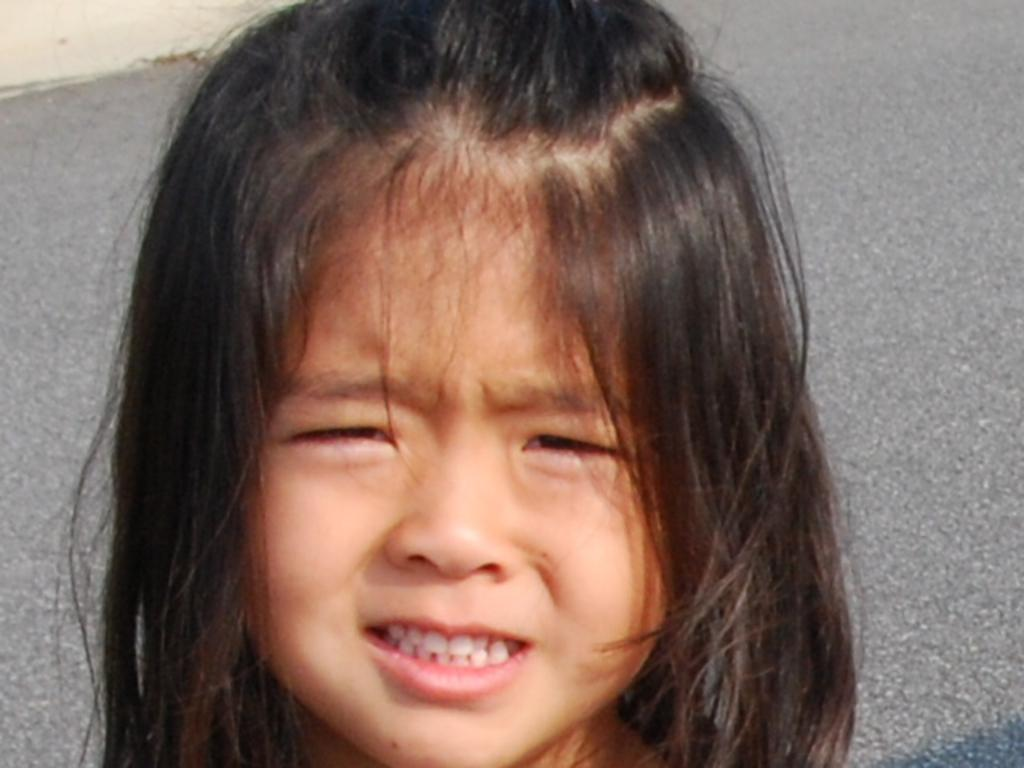Who is present in the image? There is a girl in the image. What is the girl doing in the image? The girl is crying in the image. Where is the girl located in the image? The girl is near a road in the image. What can be seen in the background of the image? There is dry land in the background of the image. What type of vein is visible on the girl's forehead in the image? There is no visible vein on the girl's forehead in the image. How many brothers does the girl have in the image? There is no information about the girl's brothers in the image. 